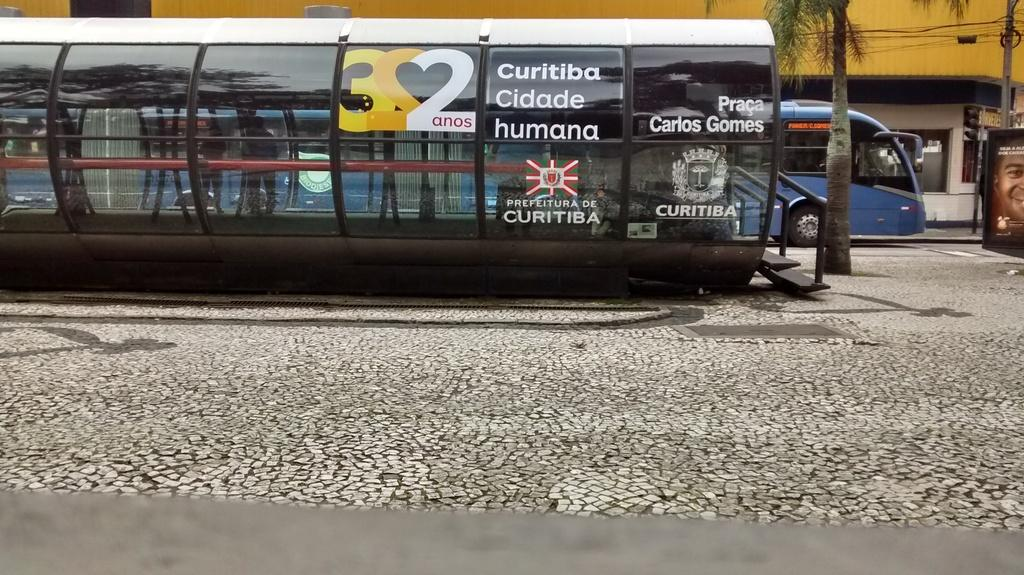<image>
Provide a brief description of the given image. A bus stop has advertisements on it including one that says Curitiba Cidade humana. 